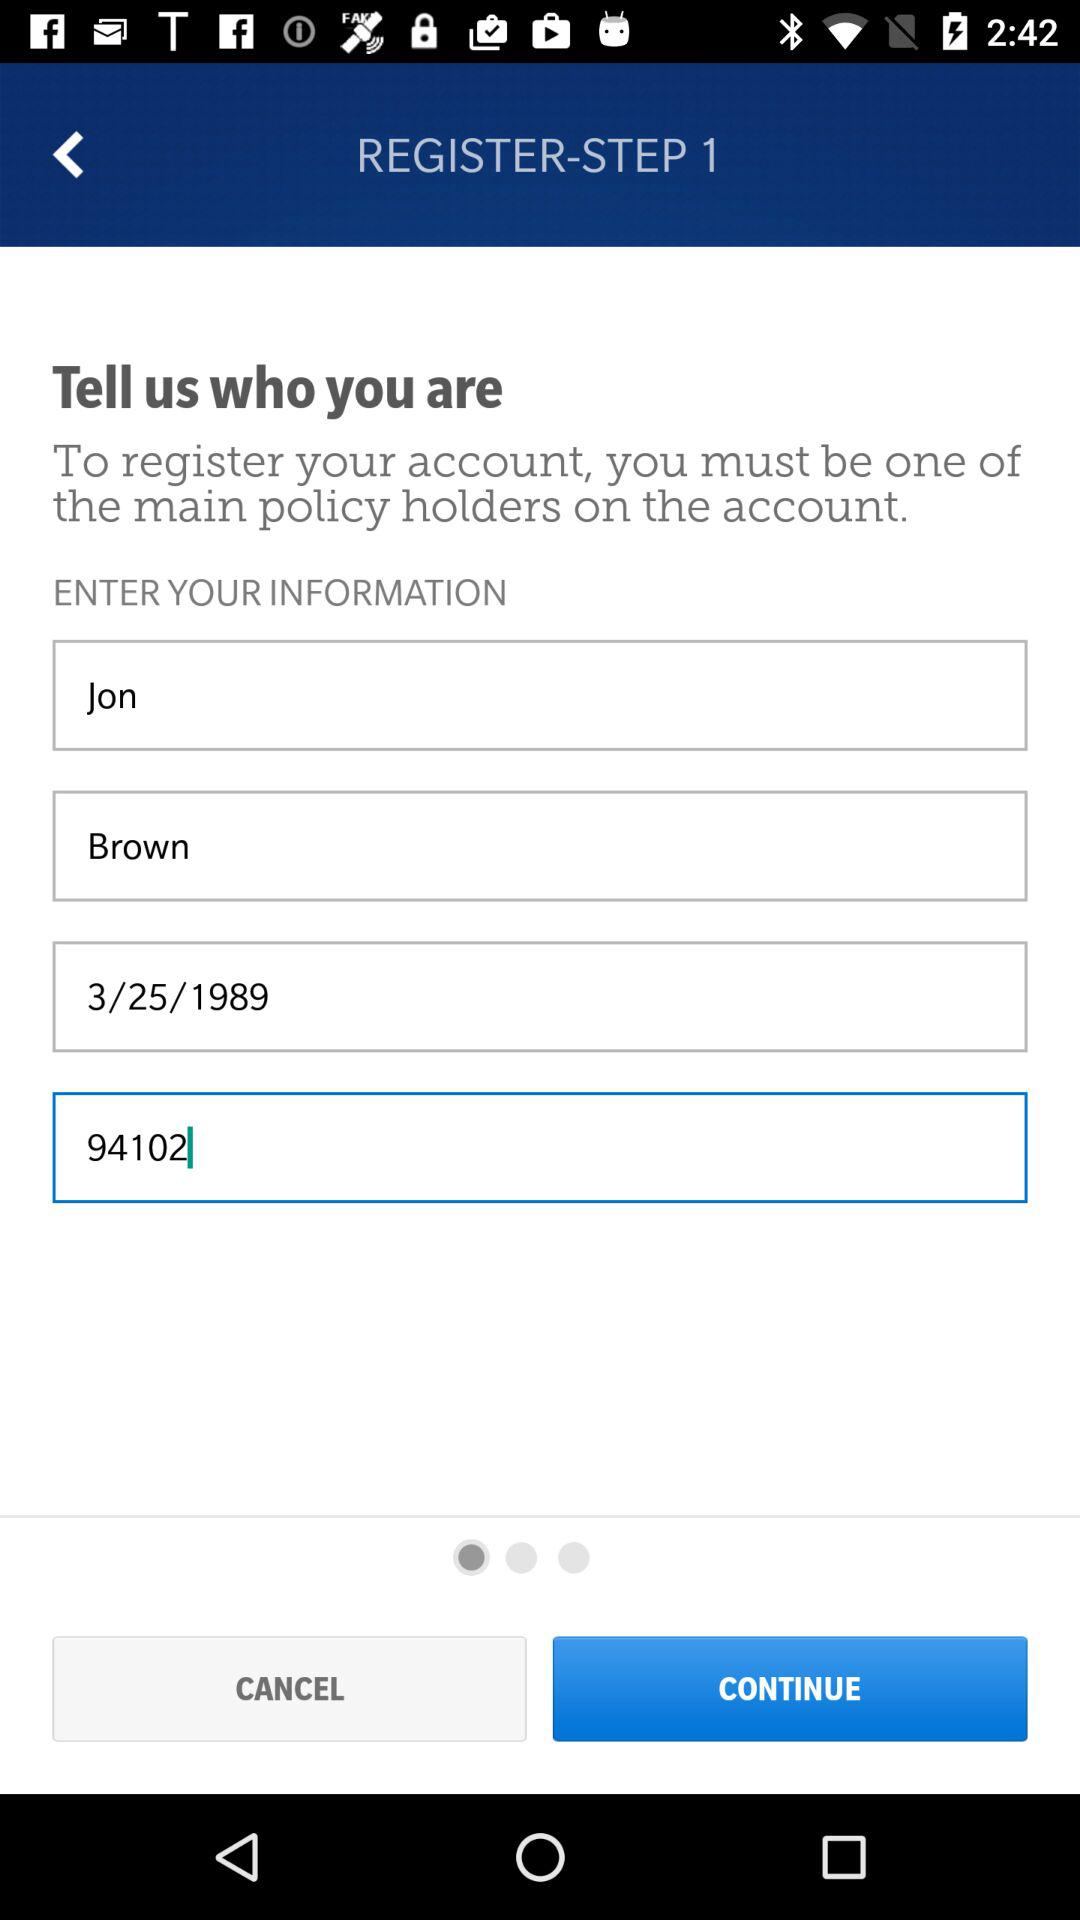What is the given account name? The account name is Jon Brown. 